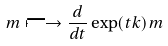<formula> <loc_0><loc_0><loc_500><loc_500>m \longmapsto \frac { d } { d t } \exp ( t k ) m</formula> 